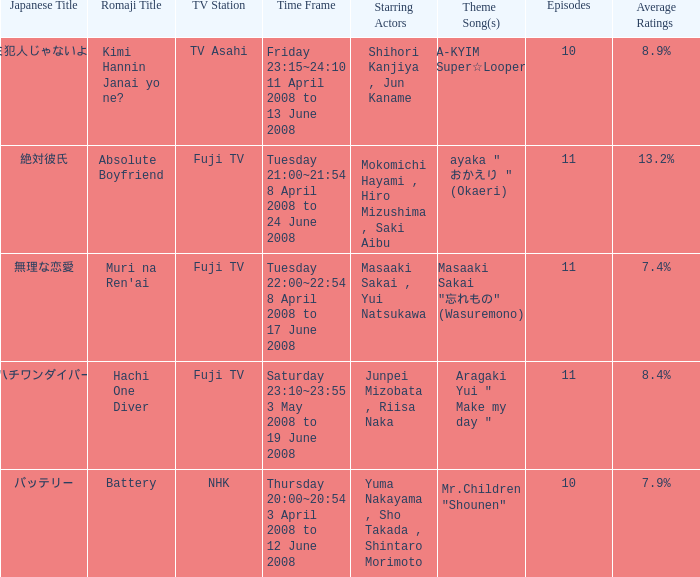Could you parse the entire table as a dict? {'header': ['Japanese Title', 'Romaji Title', 'TV Station', 'Time Frame', 'Starring Actors', 'Theme Song(s)', 'Episodes', 'Average Ratings'], 'rows': [['キミ犯人じゃないよね?', 'Kimi Hannin Janai yo ne?', 'TV Asahi', 'Friday 23:15~24:10 11 April 2008 to 13 June 2008', 'Shihori Kanjiya , Jun Kaname', 'YA-KYIM "Super☆Looper"', '10', '8.9%'], ['絶対彼氏', 'Absolute Boyfriend', 'Fuji TV', 'Tuesday 21:00~21:54 8 April 2008 to 24 June 2008', 'Mokomichi Hayami , Hiro Mizushima , Saki Aibu', 'ayaka " おかえり " (Okaeri)', '11', '13.2%'], ['無理な恋愛', "Muri na Ren'ai", 'Fuji TV', 'Tuesday 22:00~22:54 8 April 2008 to 17 June 2008', 'Masaaki Sakai , Yui Natsukawa', 'Masaaki Sakai "忘れもの" (Wasuremono)', '11', '7.4%'], ['ハチワンダイバー', 'Hachi One Diver', 'Fuji TV', 'Saturday 23:10~23:55 3 May 2008 to 19 June 2008', 'Junpei Mizobata , Riisa Naka', 'Aragaki Yui " Make my day "', '11', '8.4%'], ['バッテリー', 'Battery', 'NHK', 'Thursday 20:00~20:54 3 April 2008 to 12 June 2008', 'Yuma Nakayama , Sho Takada , Shintaro Morimoto', 'Mr.Children "Shounen"', '10', '7.9%']]} What are the romaji title(s) with the theme song "ya-kyim "super☆looper"? Kimi Hannin Janai yo ne?. 